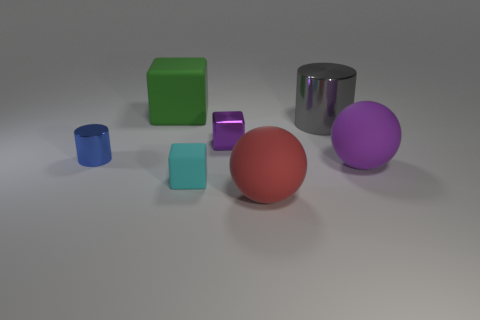Subtract all yellow cylinders. Subtract all purple spheres. How many cylinders are left? 2 Add 2 tiny metallic cylinders. How many objects exist? 9 Subtract all blocks. How many objects are left? 4 Subtract all blocks. Subtract all brown metallic cubes. How many objects are left? 4 Add 5 cyan cubes. How many cyan cubes are left? 6 Add 6 purple metallic objects. How many purple metallic objects exist? 7 Subtract 0 yellow cylinders. How many objects are left? 7 